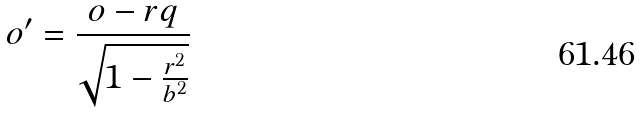Convert formula to latex. <formula><loc_0><loc_0><loc_500><loc_500>o ^ { \prime } = \frac { o - r q } { \sqrt { 1 - \frac { r ^ { 2 } } { b ^ { 2 } } } }</formula> 